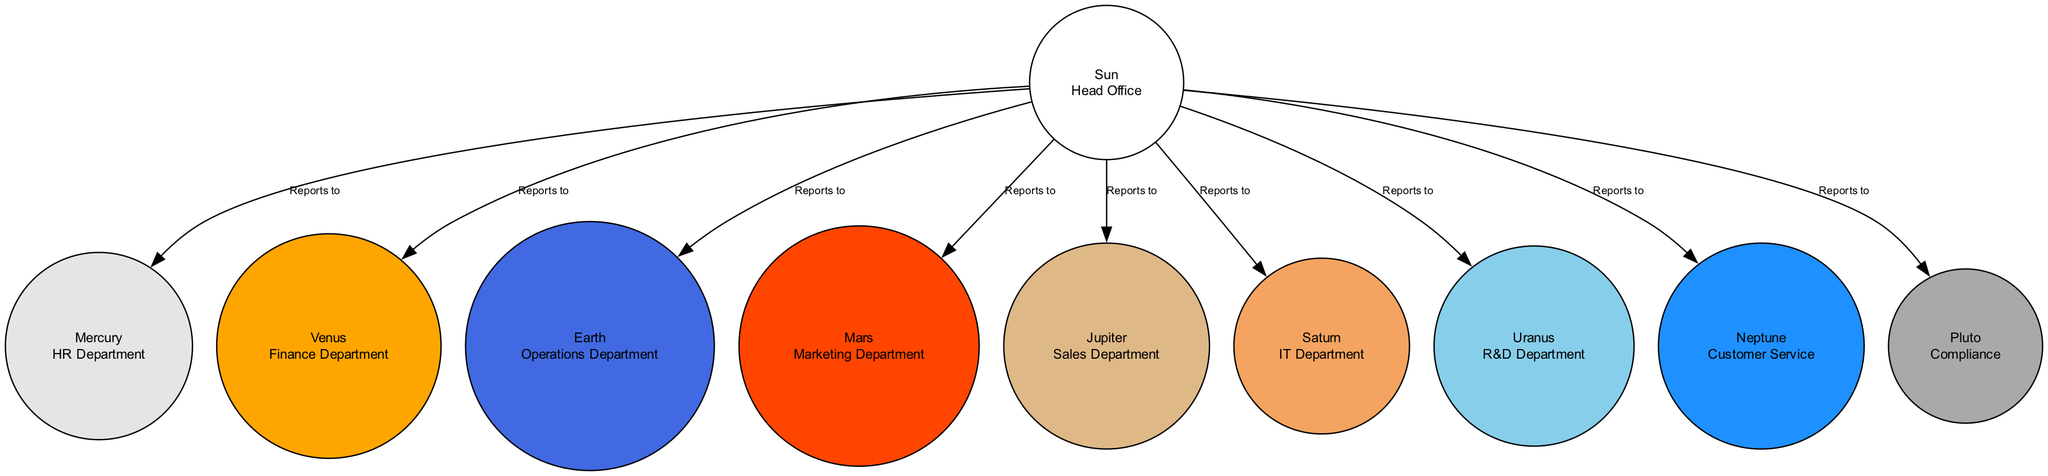what does the Sun represent in the diagram? The Sun is labeled "Head Office" and is described as the central hub for all operations and decision-making in the company structure.
Answer: Head Office how many departments report to the Sun? By examining the edges connected to the Sun, we see that there are ten nodes (including the Sun). The Sun has connections to nine other nodes (departments) indicating that these departments report to it.
Answer: 9 which department is represented by Jupiter? Based on the diagram, Jupiter is labeled as the "Sales Department," responsible for sales strategies and client relationships.
Answer: Sales Department what is the relationship between the Earth and the Sun? The edge connecting Earth to the Sun indicates a directional relationship, labeled "Reports to," meaning that the Operations Department (Earth) reports to the Head Office (Sun).
Answer: Reports to which two departments do not report to the Sun? Based on the provided data, all departments listed report directly to the Sun; there are no other departments mentioned that do not report to it. Thus, no departments are exempt from this reporting structure.
Answer: None which department is focused on market research? By reviewing the nodes, Mars is labeled as the "Marketing Department," which focuses on advertising and market research.
Answer: Marketing Department how many nodes are there in total? The diagram lists ten nodes representing different departments and the Head Office. Therefore, by counting all listed nodes, the total number of nodes can be determined to be ten.
Answer: 10 what color represents the IT Department? The IT Department, represented by Saturn in the diagram, is indicated to have a fill color of Sandy Brown.
Answer: Sandy Brown who handles customer inquiries? Neptune is labeled as "Customer Service," responsible for handling customer inquiries and support, making it clear that this department is in charge of such responsibilities.
Answer: Customer Service 